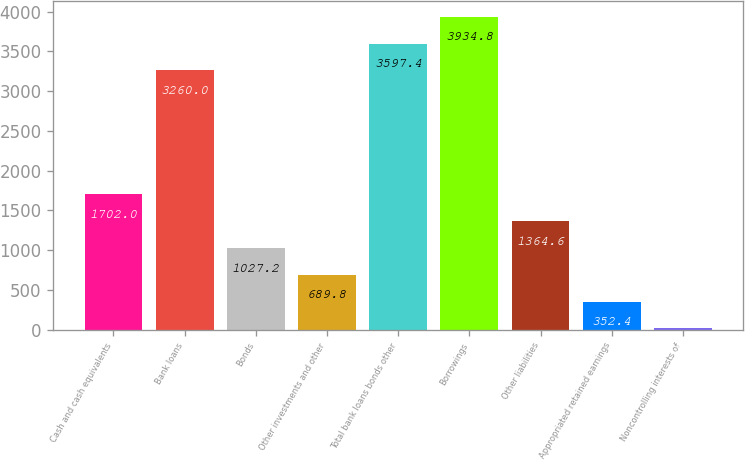Convert chart to OTSL. <chart><loc_0><loc_0><loc_500><loc_500><bar_chart><fcel>Cash and cash equivalents<fcel>Bank loans<fcel>Bonds<fcel>Other investments and other<fcel>Total bank loans bonds other<fcel>Borrowings<fcel>Other liabilities<fcel>Appropriated retained earnings<fcel>Noncontrolling interests of<nl><fcel>1702<fcel>3260<fcel>1027.2<fcel>689.8<fcel>3597.4<fcel>3934.8<fcel>1364.6<fcel>352.4<fcel>15<nl></chart> 